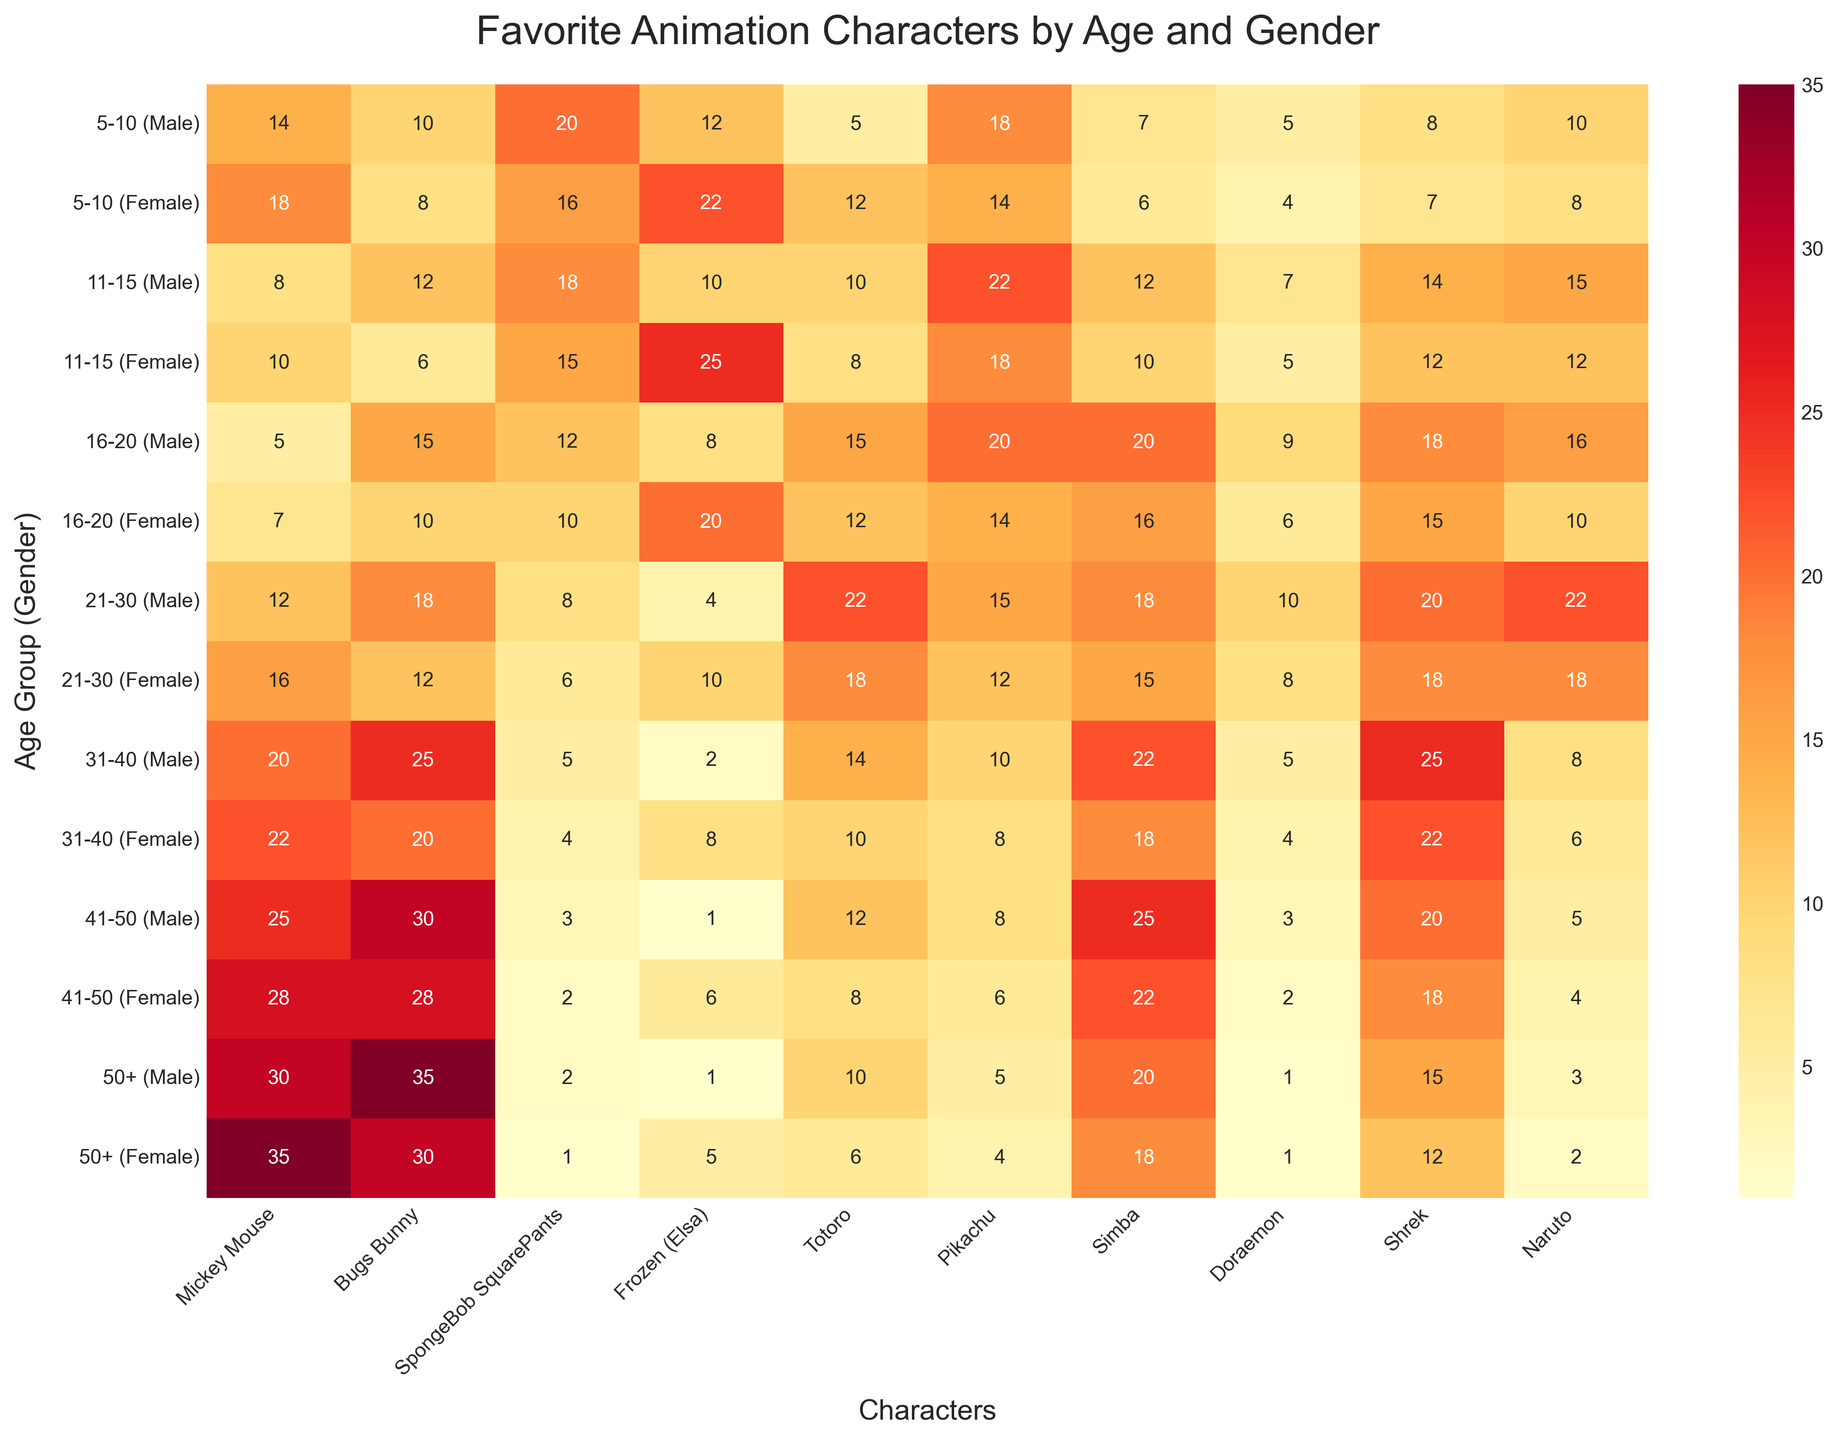What's the title of the heatmap? The title of the heatmap is usually displayed prominently at the top of the figure. In this case, the title is “Favorite Animation Characters by Age and Gender.”
Answer: Favorite Animation Characters by Age and Gender How many total characters are being analyzed in the heatmap? To determine the number of characters, count the labels along the x-axis. The characters are Mickey Mouse, Bugs Bunny, SpongeBob SquarePants, Frozen (Elsa), Totoro, Pikachu, Simba, Doraemon, Shrek, and Naruto.
Answer: 10 Which age and gender group has the highest preference for SpongeBob SquarePants? Look at the values in the SpongeBob SquarePants column and find the highest number, which is in the 5-10 Male row.
Answer: 5-10 Male For the age group 11-15, which gender prefers Pikachu more? Compare the values for Pikachu in the 11-15 Male and 11-15 Female rows. The Male group has a count of 22, while the Female group has a count of 18.
Answer: Male What’s the combined preference for Mickey Mouse in the 21-30 age group both male and female? Add the values for Mickey Mouse for both Male and Female in the 21-30 age group. 12 (Male) + 16 (Female) = 28.
Answer: 28 Who prefers Naruto more: the 31-40 Male group or the 50+ Female group? Compare the values for Naruto between the two groups. The 31-40 Male group has a count of 8, and the 50+ Female group has a count of 2.
Answer: 31-40 Male Which character is least preferred by females in the 50+ age group? Look at the values for each character in the row for 50+ Female and find the character with the lowest value. It is SpongeBob SquarePants with a count of 1.
Answer: SpongeBob SquarePants What is the average preference for Bugs Bunny across all age groups? To compute the average, sum up all the values for Bugs Bunny and then divide by the number of age and gender groups (14 values). Sum = 10+8+12+6+15+10+18+12+25+20+30+28+35+30 = 259. Average = 259/14 ≈ 18.5.
Answer: 18.5 In the 16-20 age group, do males or females have a higher combined preference for Totoro, Pikachu, and Simba? Sum up the preference values for Totoro, Pikachu, and Simba for both genders in the 16-20 age group. Males: 15+20+20 = 55, Females: 12+14+16 = 42.
Answer: Male Which character shows a decreasing trend from younger to older age groups for males? Look at the Male rows for each character and see which one shows a decreasing trend as age increases. SpongeBob SquarePants shows a clear decrease: 20 (5-10), 18 (11-15), 12 (16-20), 8 (21-30), 5 (31-40), 3 (41-50), and 2 (50+).
Answer: SpongeBob SquarePants 